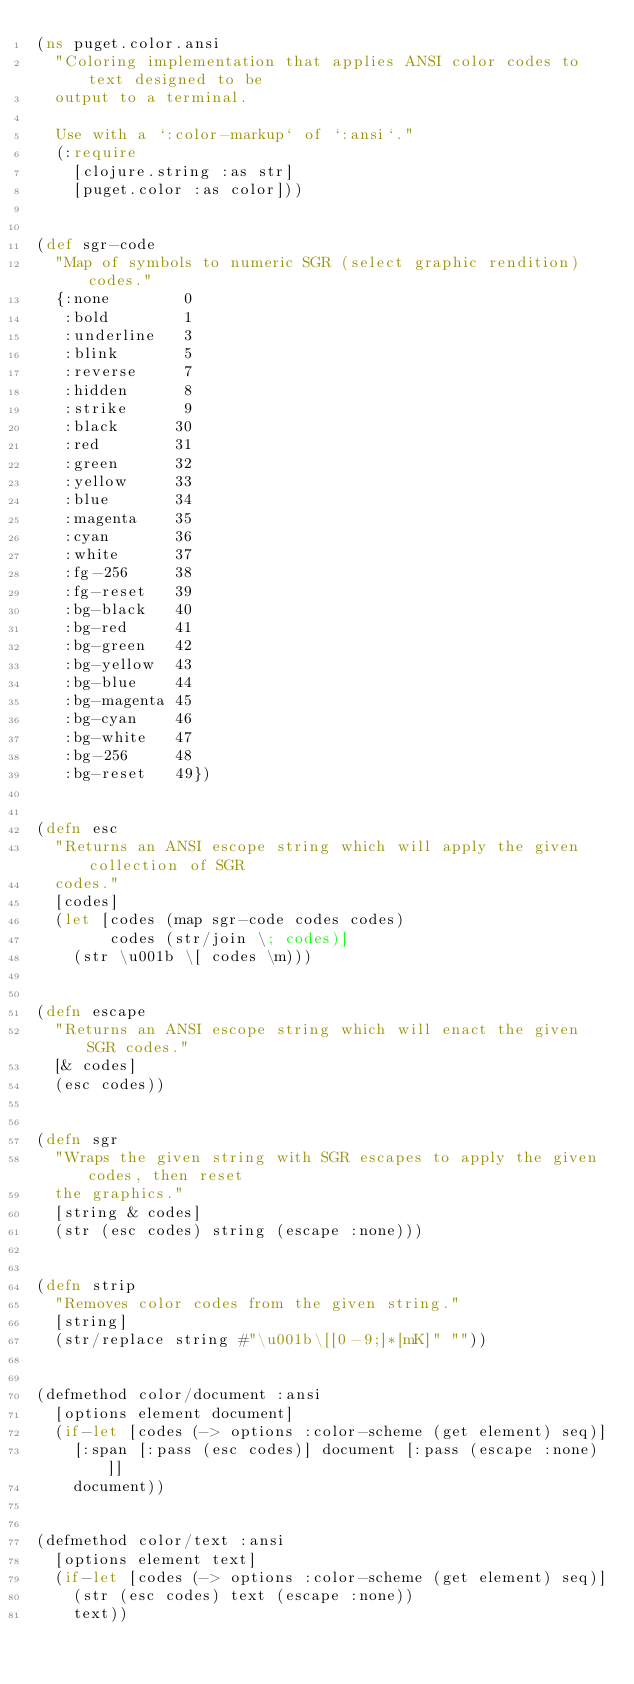Convert code to text. <code><loc_0><loc_0><loc_500><loc_500><_Clojure_>(ns puget.color.ansi
  "Coloring implementation that applies ANSI color codes to text designed to be
  output to a terminal.

  Use with a `:color-markup` of `:ansi`."
  (:require
    [clojure.string :as str]
    [puget.color :as color]))


(def sgr-code
  "Map of symbols to numeric SGR (select graphic rendition) codes."
  {:none        0
   :bold        1
   :underline   3
   :blink       5
   :reverse     7
   :hidden      8
   :strike      9
   :black      30
   :red        31
   :green      32
   :yellow     33
   :blue       34
   :magenta    35
   :cyan       36
   :white      37
   :fg-256     38
   :fg-reset   39
   :bg-black   40
   :bg-red     41
   :bg-green   42
   :bg-yellow  43
   :bg-blue    44
   :bg-magenta 45
   :bg-cyan    46
   :bg-white   47
   :bg-256     48
   :bg-reset   49})


(defn esc
  "Returns an ANSI escope string which will apply the given collection of SGR
  codes."
  [codes]
  (let [codes (map sgr-code codes codes)
        codes (str/join \; codes)]
    (str \u001b \[ codes \m)))


(defn escape
  "Returns an ANSI escope string which will enact the given SGR codes."
  [& codes]
  (esc codes))


(defn sgr
  "Wraps the given string with SGR escapes to apply the given codes, then reset
  the graphics."
  [string & codes]
  (str (esc codes) string (escape :none)))


(defn strip
  "Removes color codes from the given string."
  [string]
  (str/replace string #"\u001b\[[0-9;]*[mK]" ""))


(defmethod color/document :ansi
  [options element document]
  (if-let [codes (-> options :color-scheme (get element) seq)]
    [:span [:pass (esc codes)] document [:pass (escape :none)]]
    document))


(defmethod color/text :ansi
  [options element text]
  (if-let [codes (-> options :color-scheme (get element) seq)]
    (str (esc codes) text (escape :none))
    text))
</code> 